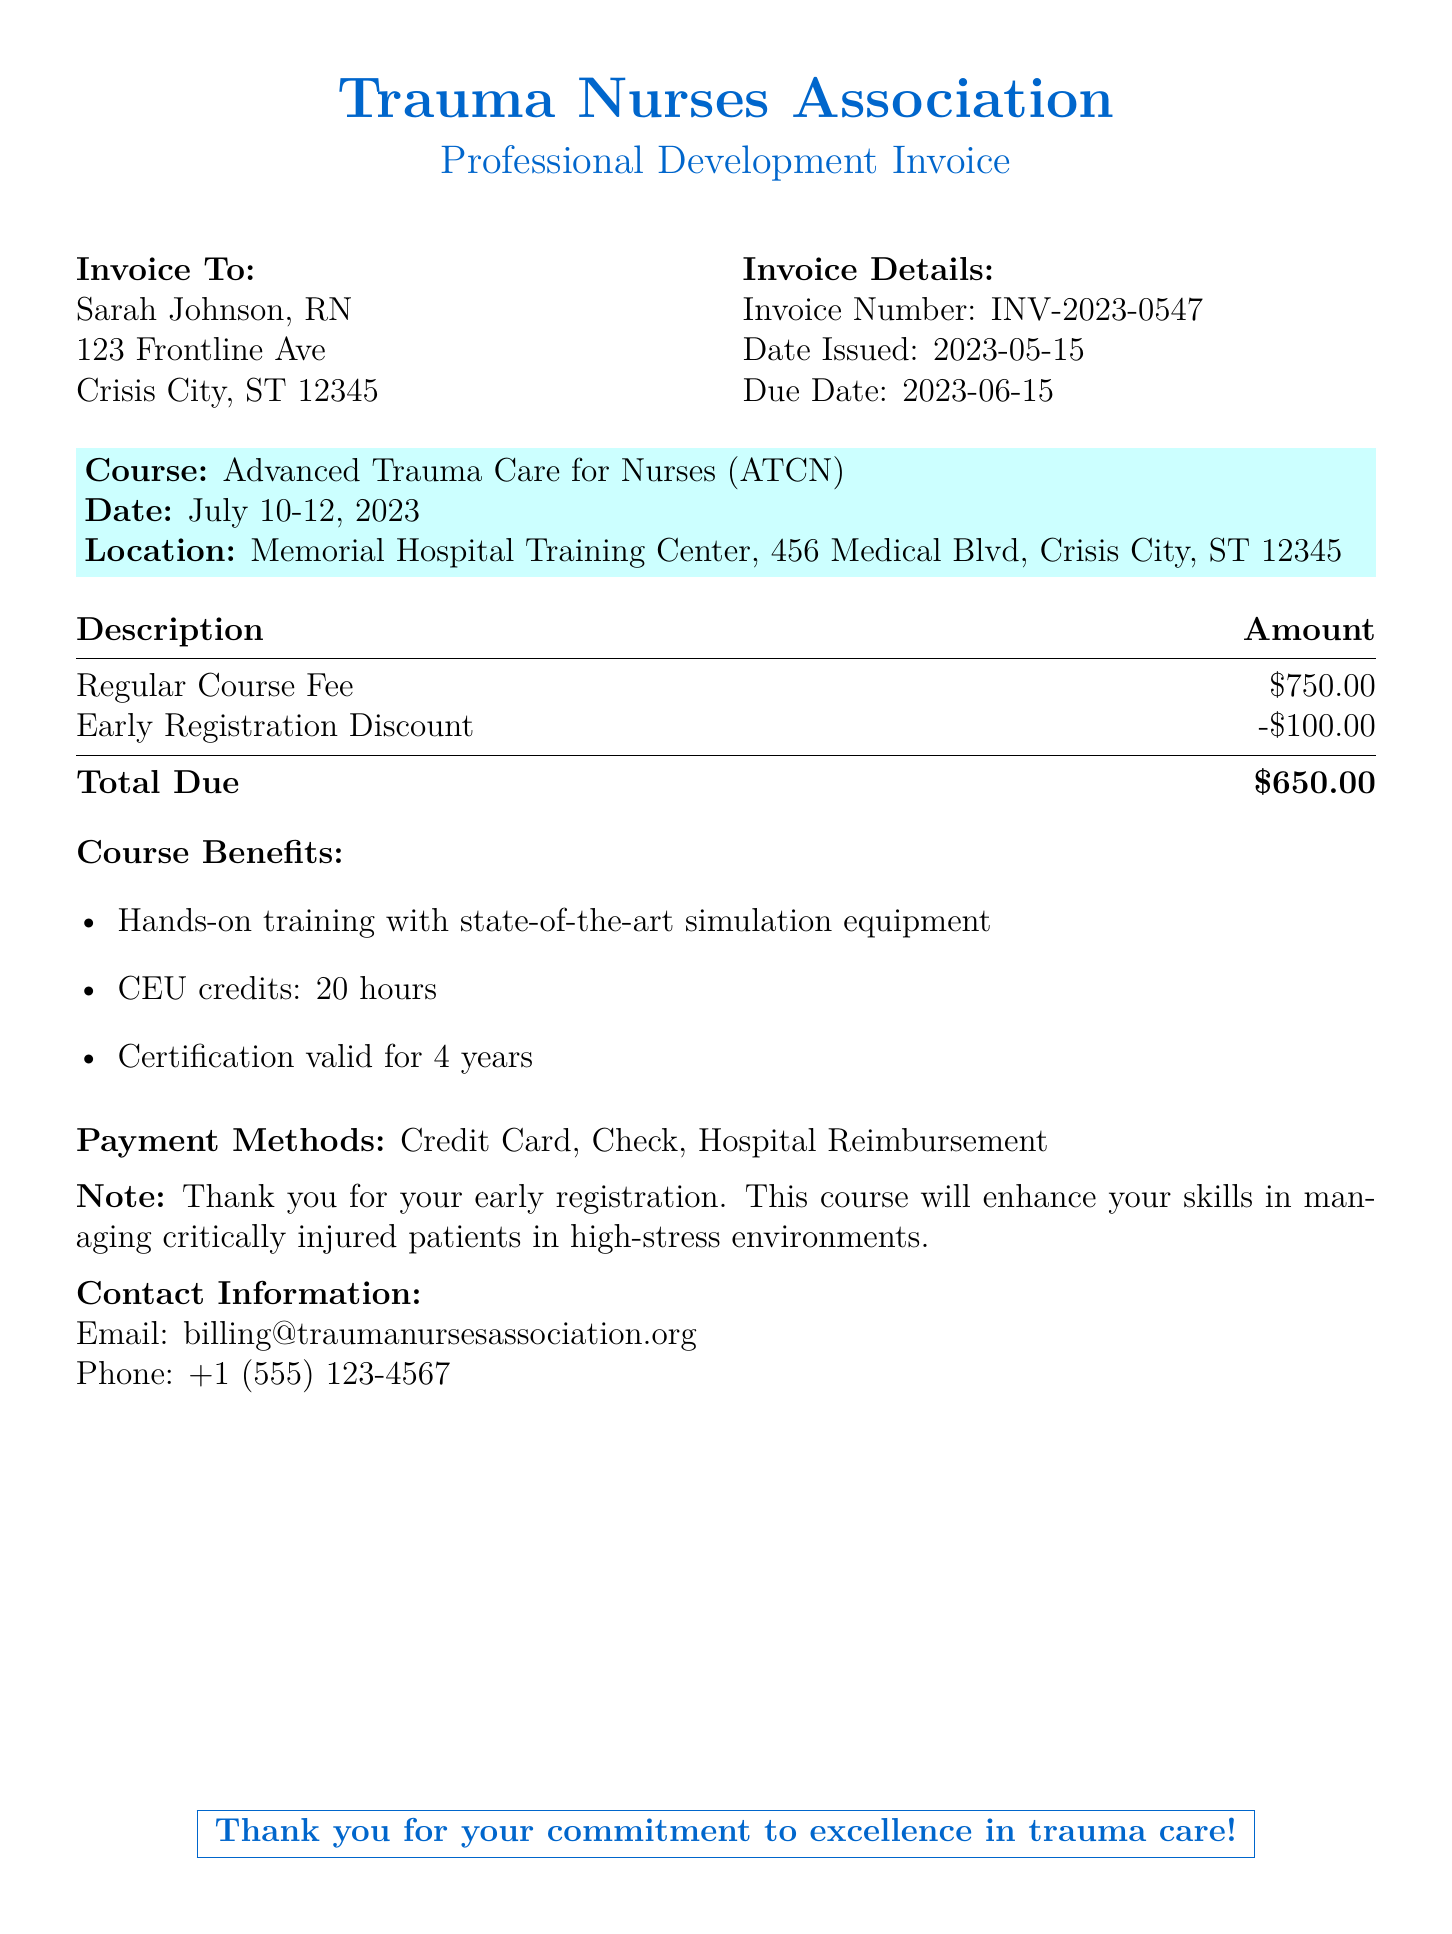What is the invoice number? The invoice number is a unique identifier for the document and can be found under the "Invoice Details" section.
Answer: INV-2023-0547 What is the total amount due? The total amount due is found at the bottom of the payment details section after accounting for discounts.
Answer: $650.00 When is the due date for payment? The due date can be located in the "Invoice Details" section of the document.
Answer: 2023-06-15 What is the early registration discount amount? The document lists the early registration discount applied to the regular fee.
Answer: -$100.00 How many CEU credits does the course provide? This information is included in the "Course Benefits" section detailing the credits awarded.
Answer: 20 hours What date does the training course take place? The training course date is specified in the course details section of the invoice.
Answer: July 10-12, 2023 Where is the training course location? The location of the training is provided in the course details of the invoice.
Answer: Memorial Hospital Training Center, 456 Medical Blvd, Crisis City, ST 12345 What methods of payment are accepted? The methods of payment can be found towards the bottom of the document, listing how the invoice can be settled.
Answer: Credit Card, Check, Hospital Reimbursement Why is the course beneficial to me as a nurse? The "Course Benefits" section outlines the advantages of attending the training and improving skills.
Answer: Hands-on training, CEU credits, certification validity 